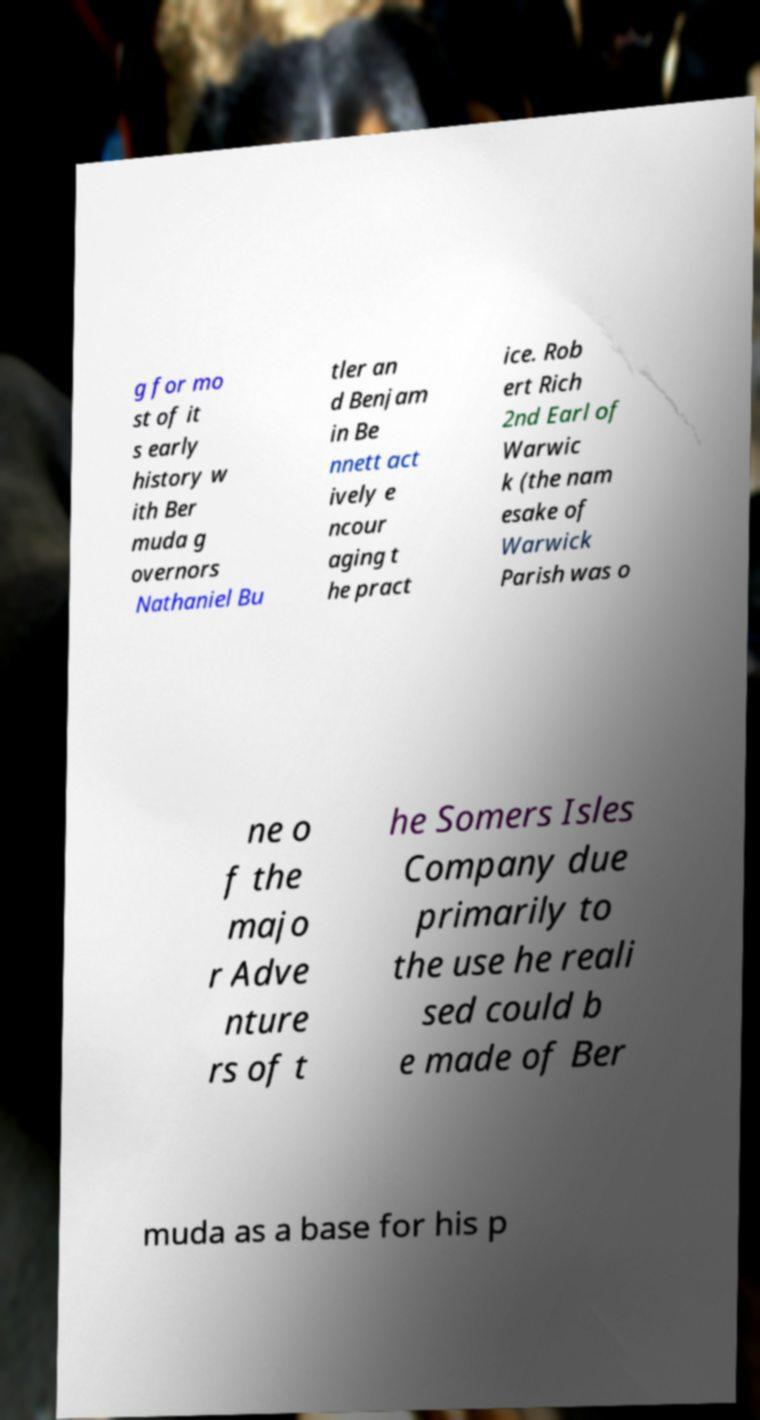Can you read and provide the text displayed in the image?This photo seems to have some interesting text. Can you extract and type it out for me? g for mo st of it s early history w ith Ber muda g overnors Nathaniel Bu tler an d Benjam in Be nnett act ively e ncour aging t he pract ice. Rob ert Rich 2nd Earl of Warwic k (the nam esake of Warwick Parish was o ne o f the majo r Adve nture rs of t he Somers Isles Company due primarily to the use he reali sed could b e made of Ber muda as a base for his p 